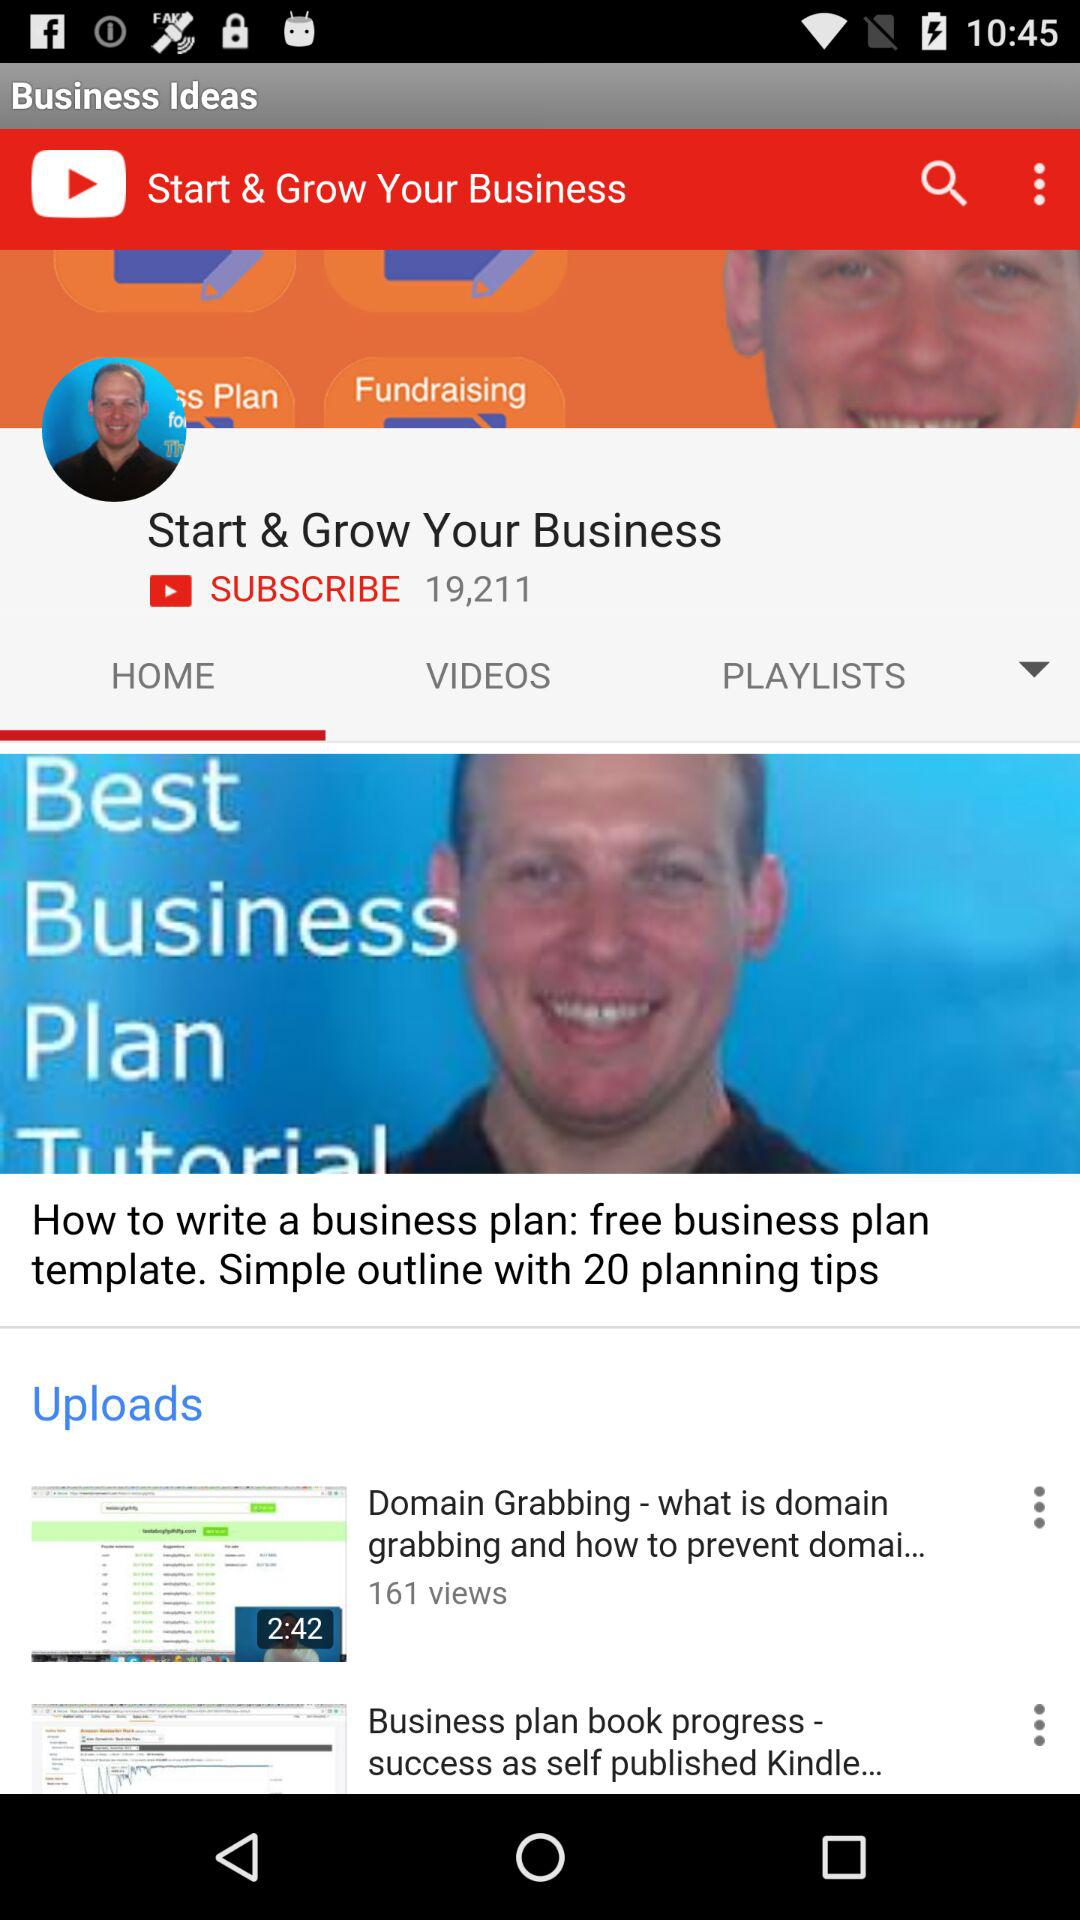Which tab has been selected? The tab that has been selected is "HOME". 